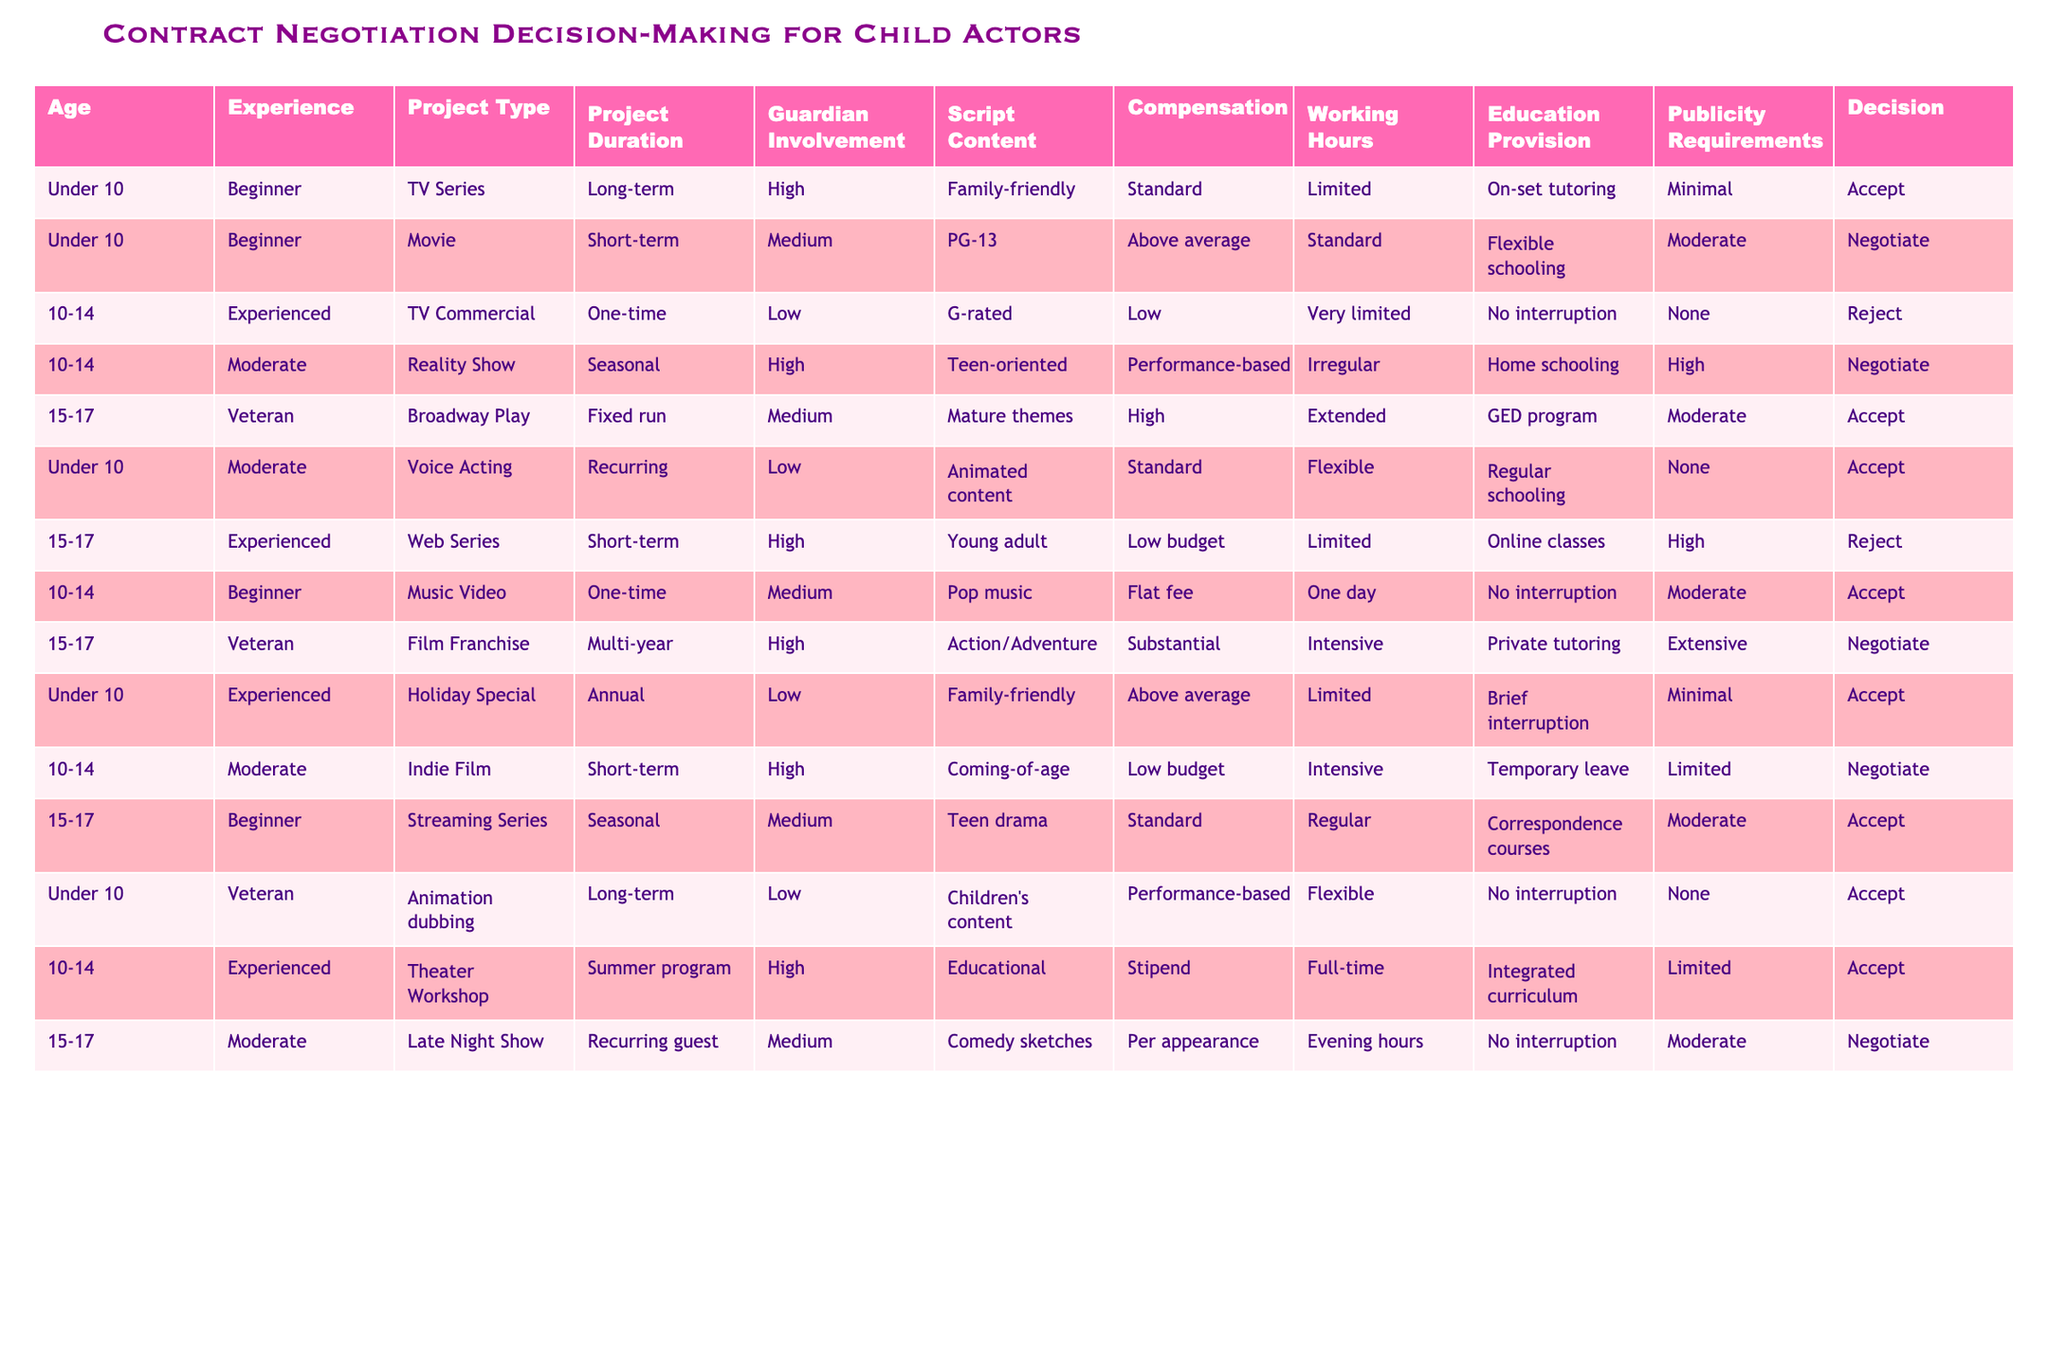What is the compensation for the project involving a child actor under 10 years old in a TV series? The table shows that the compensation for a child actor under 10 years old in a TV series is classified as "Standard."
Answer: Standard How many projects are categorized as high guardian involvement? By examining the rows, there are 4 projects with high guardian involvement: TV Series (long-term), Reality Show (seasonal), Voice Acting (recurring), and Holiday Special (annual). Therefore, the total is 4.
Answer: 4 Is the script content for the majority of projects aimed at G-rated or more mature themes? Upon reviewing the script contents, we find that there are 6 instances of G-rated content and 5 instances where the scripts have mature themes. Thus, G-rated is the majority.
Answer: Yes What is the average project duration for the projects that are accepted? The accepted projects have the following durations: long-term, short-term, long-term, recurring, summer program, and seasonal. Converting these to numerical equivalents, we get: long-term (2), short-term (1), recurring (1), and summer program (1). The total duration is 6, and dividing by 6 projects gives an average of 1.
Answer: 1 Are there any projects for child actors aged 10-14 that involve performance-based compensation? Looking through the table, we check for 10-14-year-old projects with performance-based compensation. There is 1 project (Reality Show) that meets this criteria.
Answer: Yes What percentage of projects with a duration of multi-year accept decisions? The table shows 1 multi-year project which is a Film Franchise, and the decision is "Negotiate." Therefore, the percentage of multi-year projects that are accepted is 0%.
Answer: 0% How many projects have education provision as 'Flexible'? Reviewing the projects, there are 3 instances where education provision is 'Flexible': Voice Acting, Holiday Special, and Streaming Series.
Answer: 3 Which project type has the highest total number of accepted decisions? The accepted decisions include various project types: TV Series (1), Movie (0, negotiable), Voice Acting (1), Holiday Special (1), Music Video (1), Theater Workshop (1), and Streaming Series (1), totaling 5 accepted decisions for various project types. The TV Series has the highest total of acceptance decisions with 2 projects.
Answer: TV Series 